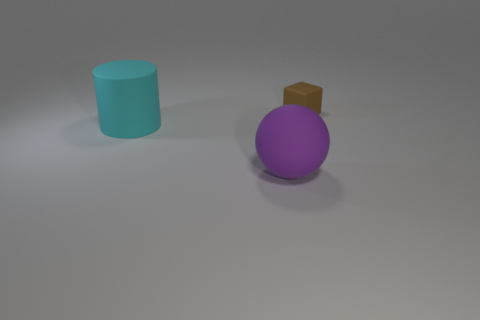Subtract all cyan spheres. Subtract all blue cylinders. How many spheres are left? 1 Add 1 tiny yellow shiny cubes. How many objects exist? 4 Subtract all cylinders. How many objects are left? 2 Subtract all brown shiny blocks. Subtract all large things. How many objects are left? 1 Add 1 tiny rubber blocks. How many tiny rubber blocks are left? 2 Add 2 small brown matte blocks. How many small brown matte blocks exist? 3 Subtract 0 green cylinders. How many objects are left? 3 